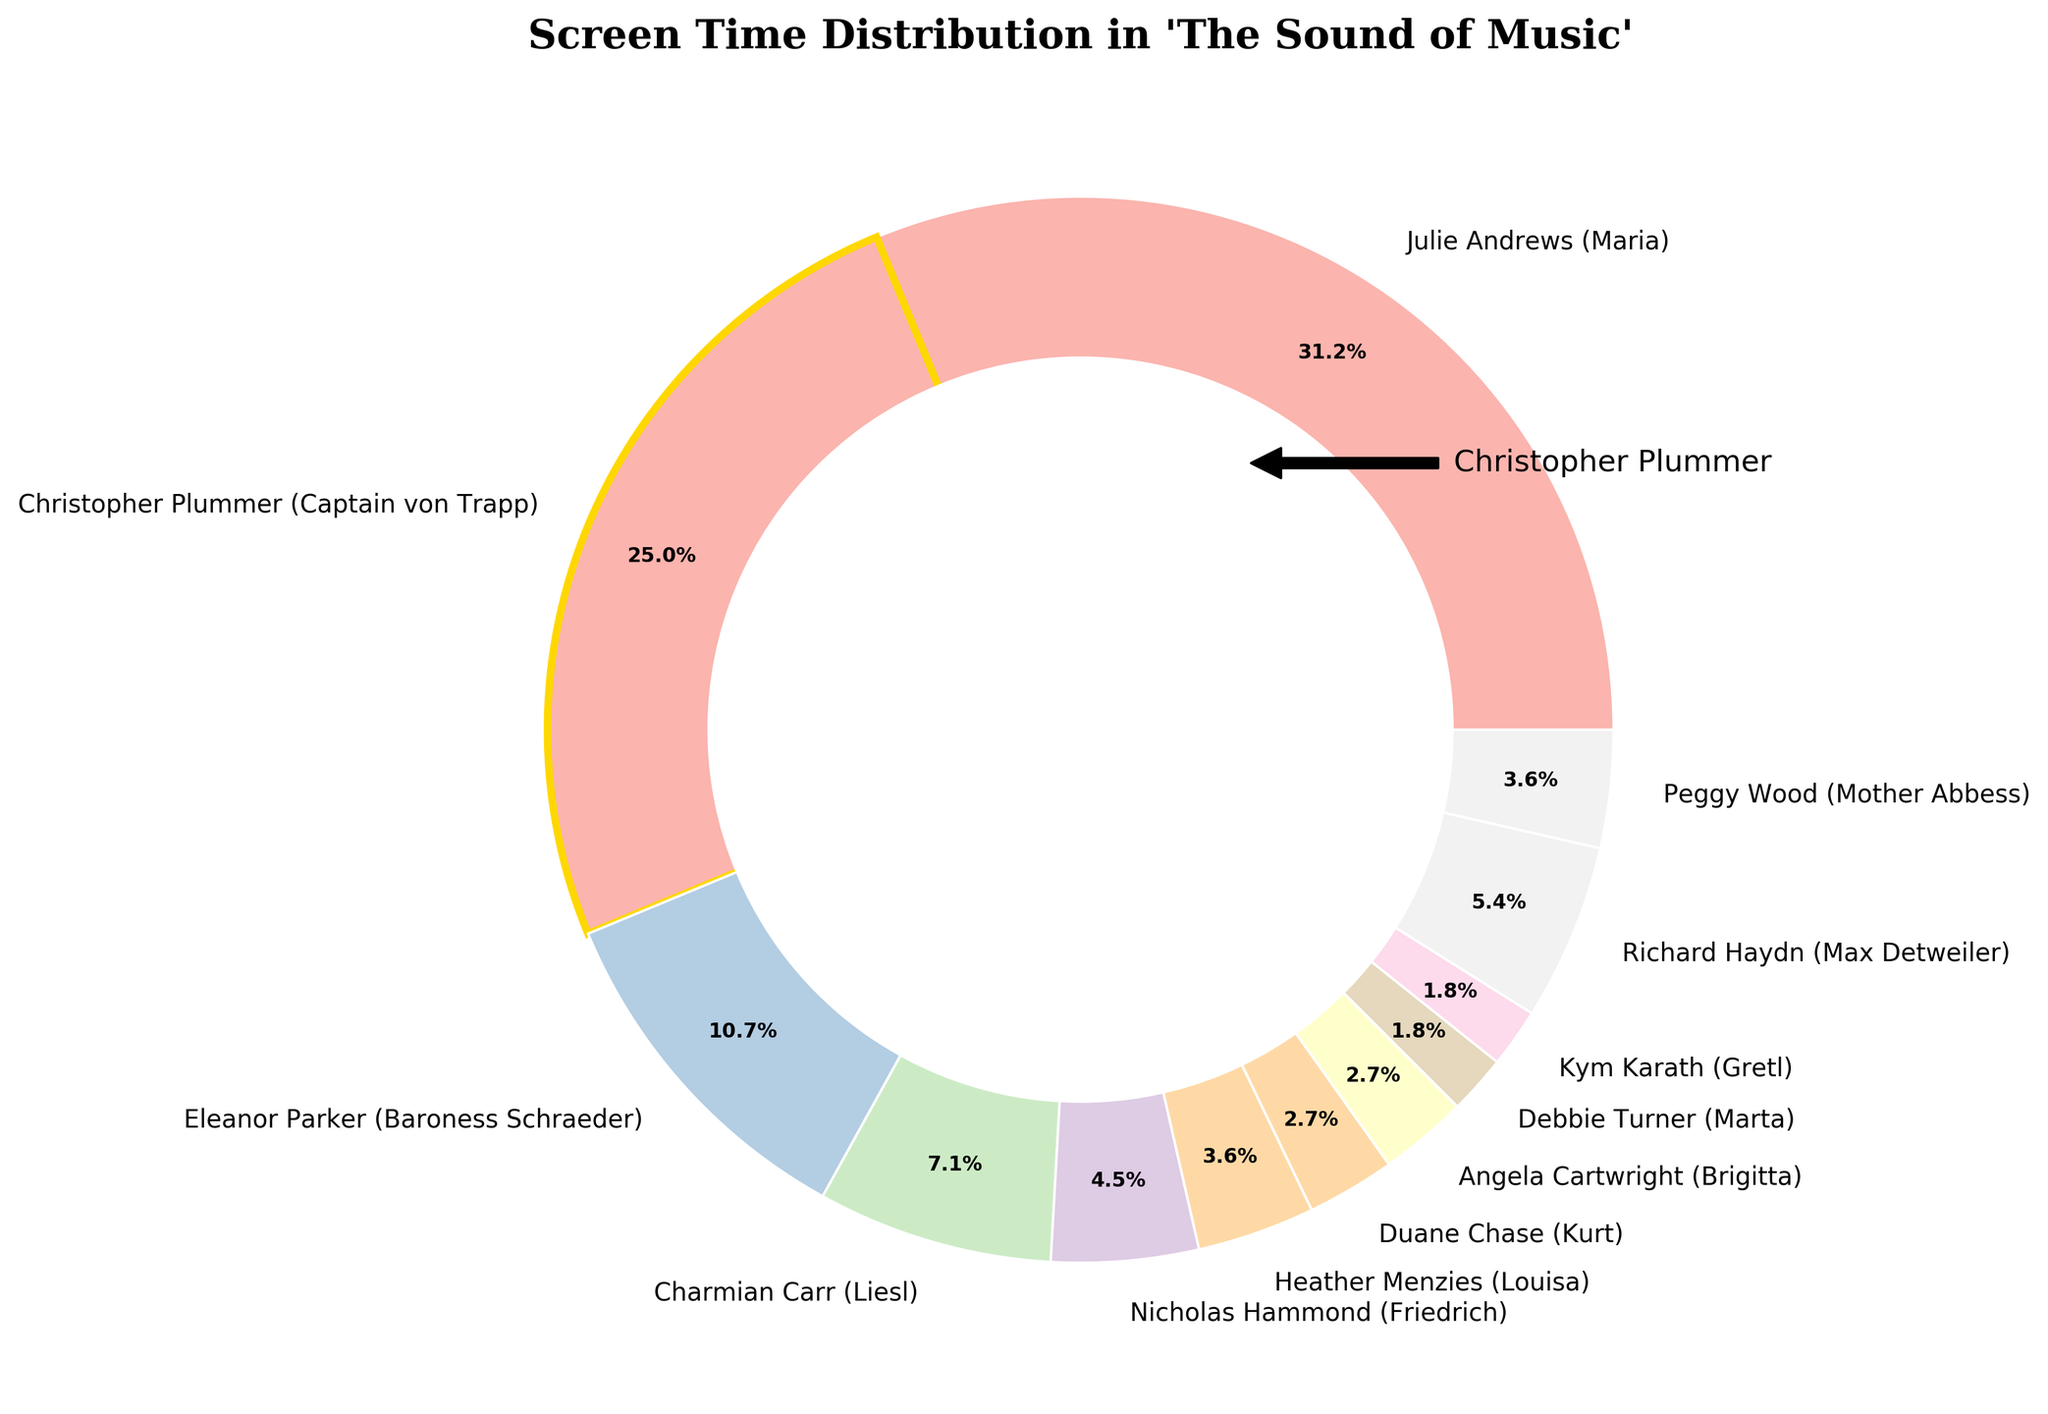Which character has the highest screen time percentage? By looking at the figure, we see the largest slice corresponding to "Julie Andrews (Maria)", which covers 35% of the total screen time.
Answer: Julie Andrews (Maria) Which character has a screen time percentage closest to 10%? The figure shows distinct slices for each character, and "Eleanor Parker (Baroness Schraeder)" has a screen time percentage of 12%, which is closest to 10% compared to other characters.
Answer: Eleanor Parker (Baroness Schraeder) How much more screen time does Julie Andrews (Maria) have compared to Nicholas Hammond (Friedrich)? "Julie Andrews (Maria)" has 35% screen time and "Nicholas Hammond (Friedrich)" has 5%. The difference is calculated by subtracting 5% from 35%, which equals 30%.
Answer: 30% What is the combined screen time percentage of all the von Trapp children characters? The von Trapp children with their screen times are "Charmian Carr (Liesl)" (8%), "Nicholas Hammond (Friedrich)" (5%), "Heather Menzies (Louisa)" (4%), "Duane Chase (Kurt)" (3%), "Angela Cartwright (Brigitta)" (3%), "Debbie Turner (Marta)" (2%), and "Kym Karath (Gretl)" (2%). Summing these up: 8 + 5 + 4 + 3 + 3 + 2 + 2 = 27%.
Answer: 27% Which character's screen time is highlighted with a gold-edged slice? The slice with a gold edge highlights the character "Christopher Plummer (Captain von Trapp)". This visual clue stands out from the rest of the slices.
Answer: Christopher Plummer (Captain von Trapp) Whose screen time percentage is closest to half of Christopher Plummer's (Captain von Trapp)? Christopher Plummer has 28% screen time, half of which is 14%. The screen time percentages are checked to find that "Eleanor Parker (Baroness Schraeder)" with 12% is closest to this value.
Answer: Eleanor Parker (Baroness Schraeder) Which characters have exactly 3% of screen time each? Observing the labeled slices in the pie chart, "Duane Chase (Kurt)" and "Angela Cartwright (Brigitta)" each have a screen time percentage of 3%.
Answer: Duane Chase (Kurt) and Angela Cartwright (Brigitta) What is the total screen time percentage for characters with less than 5% screen time? Characters with screen times below 5% are "Duane Chase (Kurt)" (3%), "Angela Cartwright (Brigitta)" (3%), "Debbie Turner (Marta)" (2%), and "Kym Karath (Gretl)" (2%). Summing these up: 3 + 3 + 2 + 2 = 10%.
Answer: 10% How does the screen time of Peggy Wood (Mother Abbess) compare with that of Heather Menzies (Louisa)? Peggy Wood (Mother Abbess) has 4% screen time and Heather Menzies (Louisa) also has 4% screen time. Their screen times are equal.
Answer: Equal Which character has the closest screen time to Christopher Plummer (Captain von Trapp)? Christopher Plummer (Captain von Trapp) has 28% screen time. The next closest character is "Julie Andrews (Maria)" with 35% screen time. Checking other characters, none are closer than Julie Andrews.
Answer: Julie Andrews (Maria) 